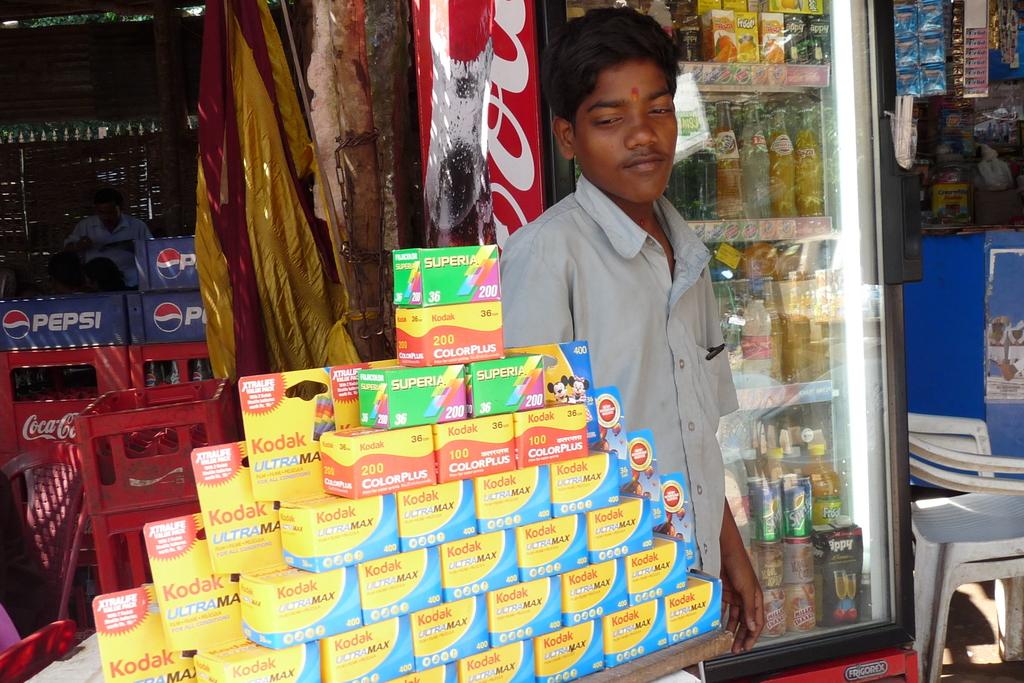What brand of soda do they sell?
Give a very brief answer. Pepsi. What camera brand is shown in the image?
Ensure brevity in your answer.  Kodak. 